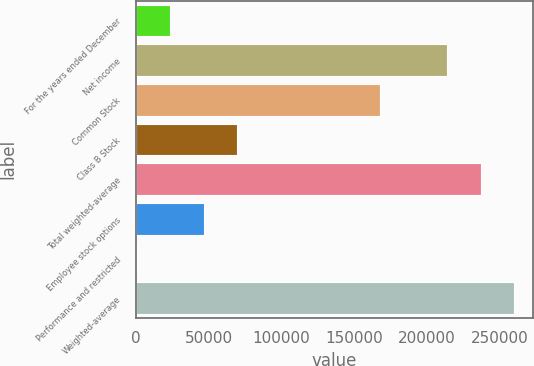Convert chart. <chart><loc_0><loc_0><loc_500><loc_500><bar_chart><fcel>For the years ended December<fcel>Net income<fcel>Common Stock<fcel>Class B Stock<fcel>Total weighted-average<fcel>Employee stock options<fcel>Performance and restricted<fcel>Weighted-average<nl><fcel>23620.1<fcel>214154<fcel>168050<fcel>69804.3<fcel>237246<fcel>46712.2<fcel>528<fcel>260338<nl></chart> 